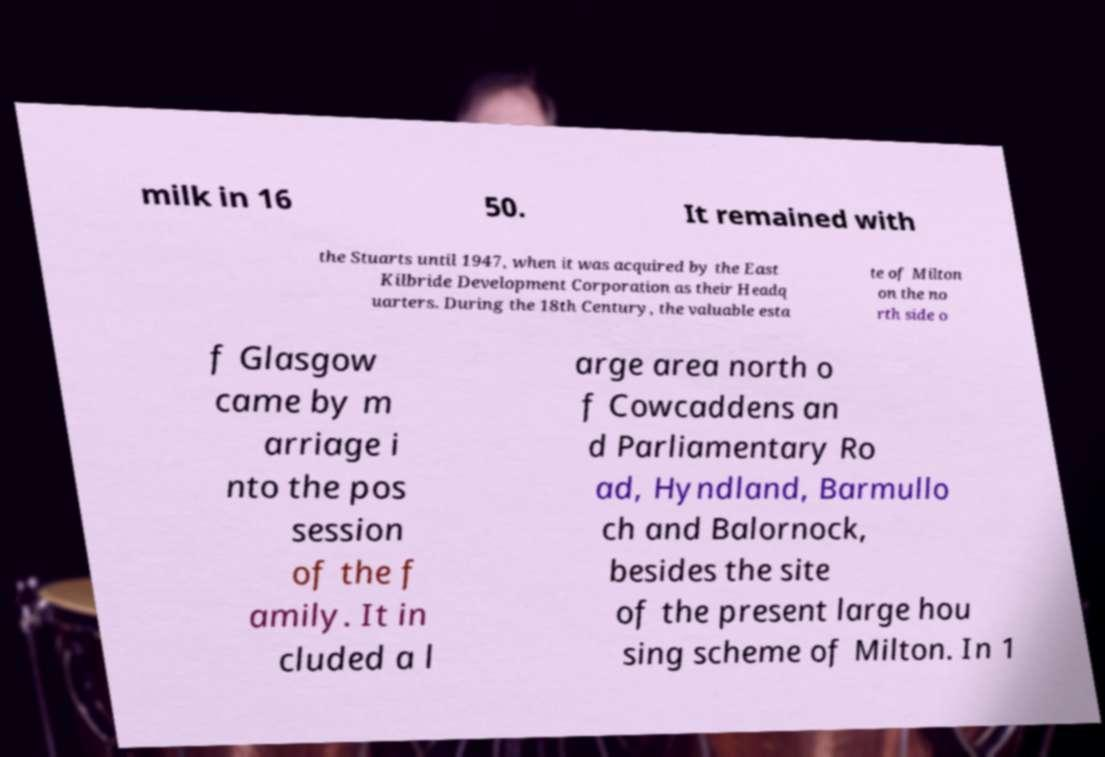There's text embedded in this image that I need extracted. Can you transcribe it verbatim? milk in 16 50. It remained with the Stuarts until 1947, when it was acquired by the East Kilbride Development Corporation as their Headq uarters. During the 18th Century, the valuable esta te of Milton on the no rth side o f Glasgow came by m arriage i nto the pos session of the f amily. It in cluded a l arge area north o f Cowcaddens an d Parliamentary Ro ad, Hyndland, Barmullo ch and Balornock, besides the site of the present large hou sing scheme of Milton. In 1 